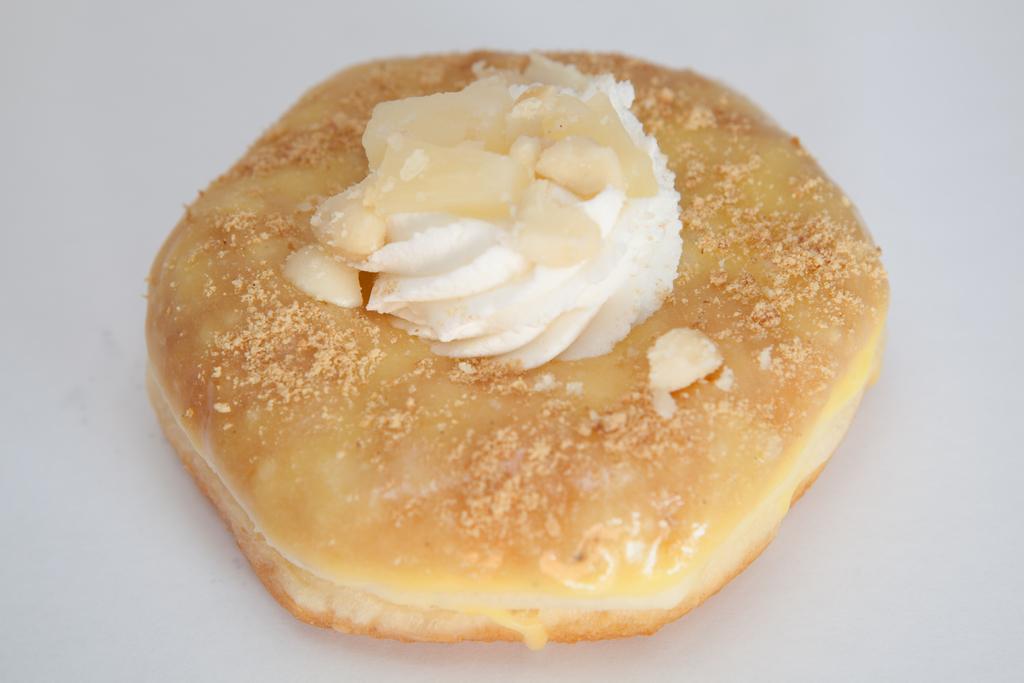Please provide a concise description of this image. In this picture I can see a food item on an object. 